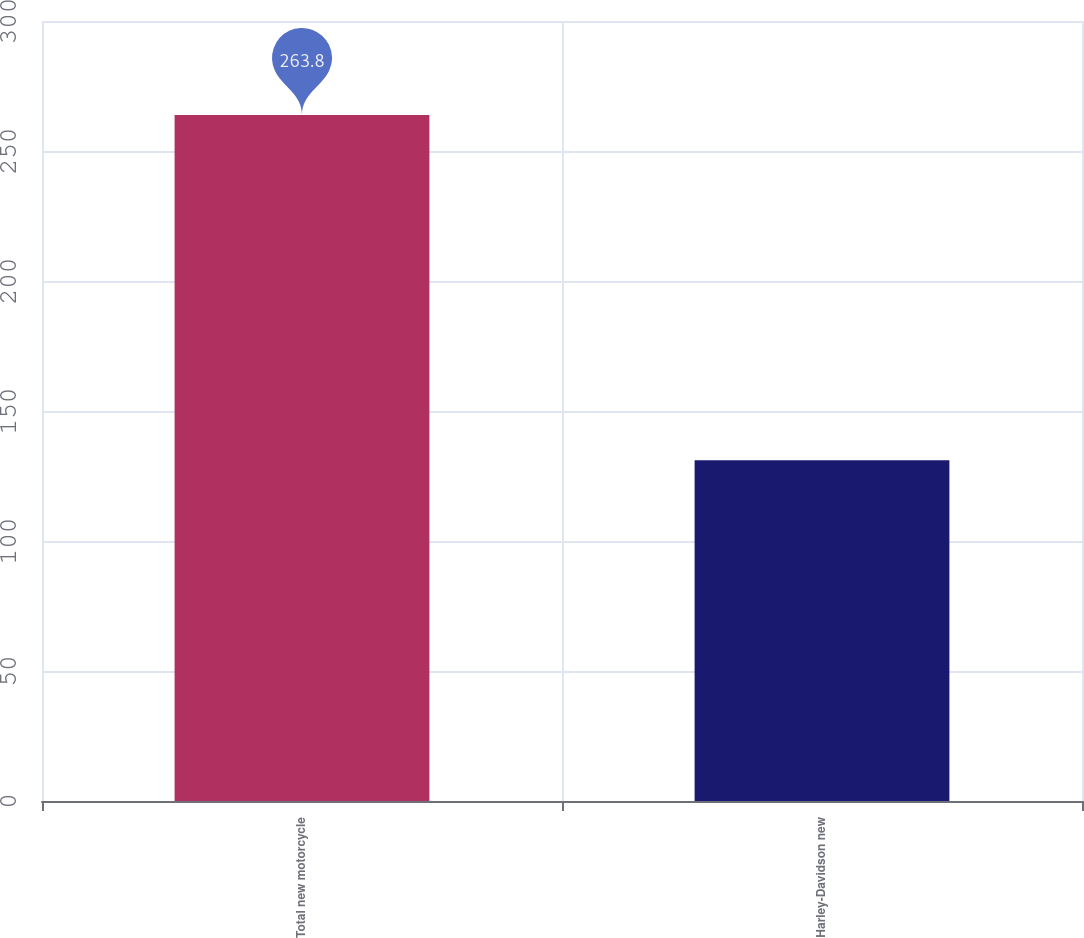Convert chart. <chart><loc_0><loc_0><loc_500><loc_500><bar_chart><fcel>Total new motorcycle<fcel>Harley-Davidson new<nl><fcel>263.8<fcel>131.1<nl></chart> 